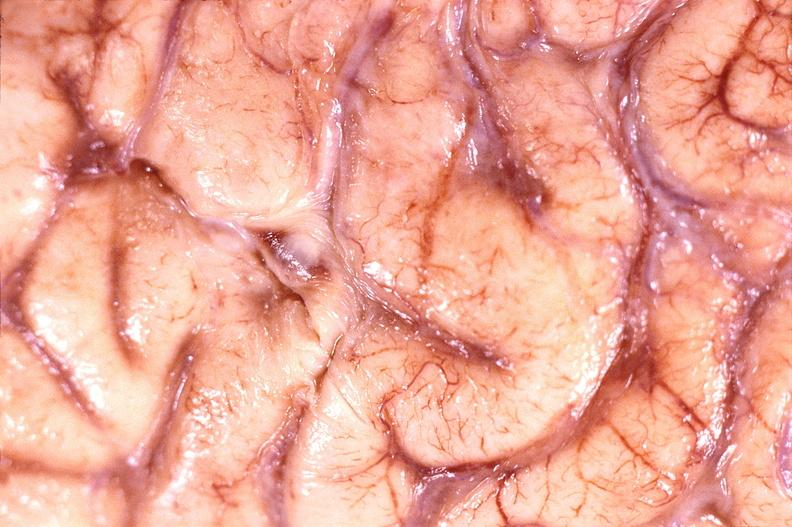s nervous present?
Answer the question using a single word or phrase. Yes 